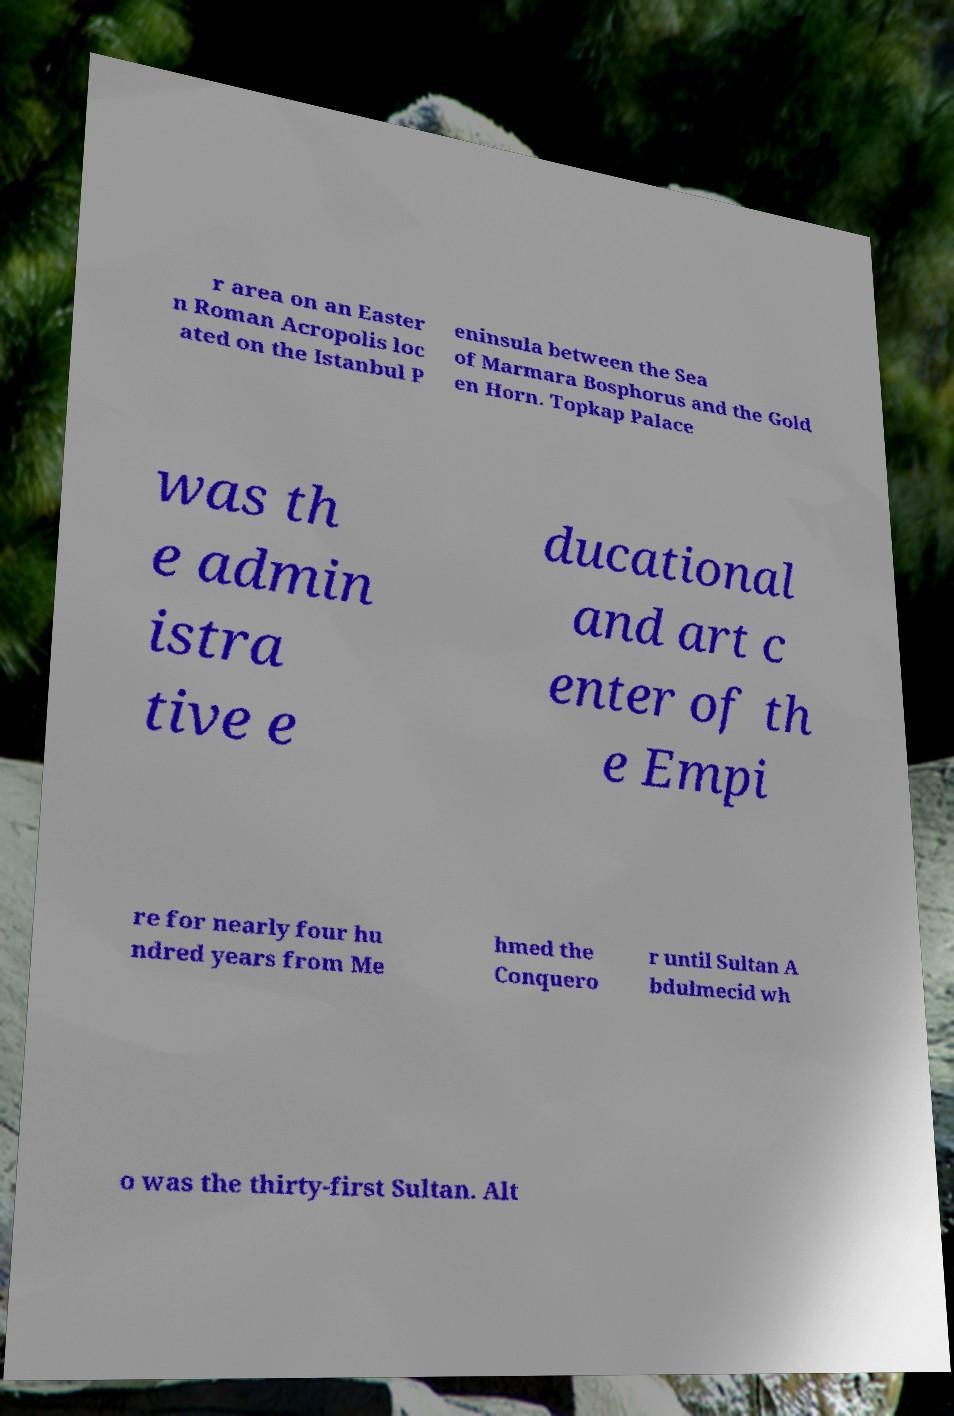For documentation purposes, I need the text within this image transcribed. Could you provide that? r area on an Easter n Roman Acropolis loc ated on the Istanbul P eninsula between the Sea of Marmara Bosphorus and the Gold en Horn. Topkap Palace was th e admin istra tive e ducational and art c enter of th e Empi re for nearly four hu ndred years from Me hmed the Conquero r until Sultan A bdulmecid wh o was the thirty-first Sultan. Alt 